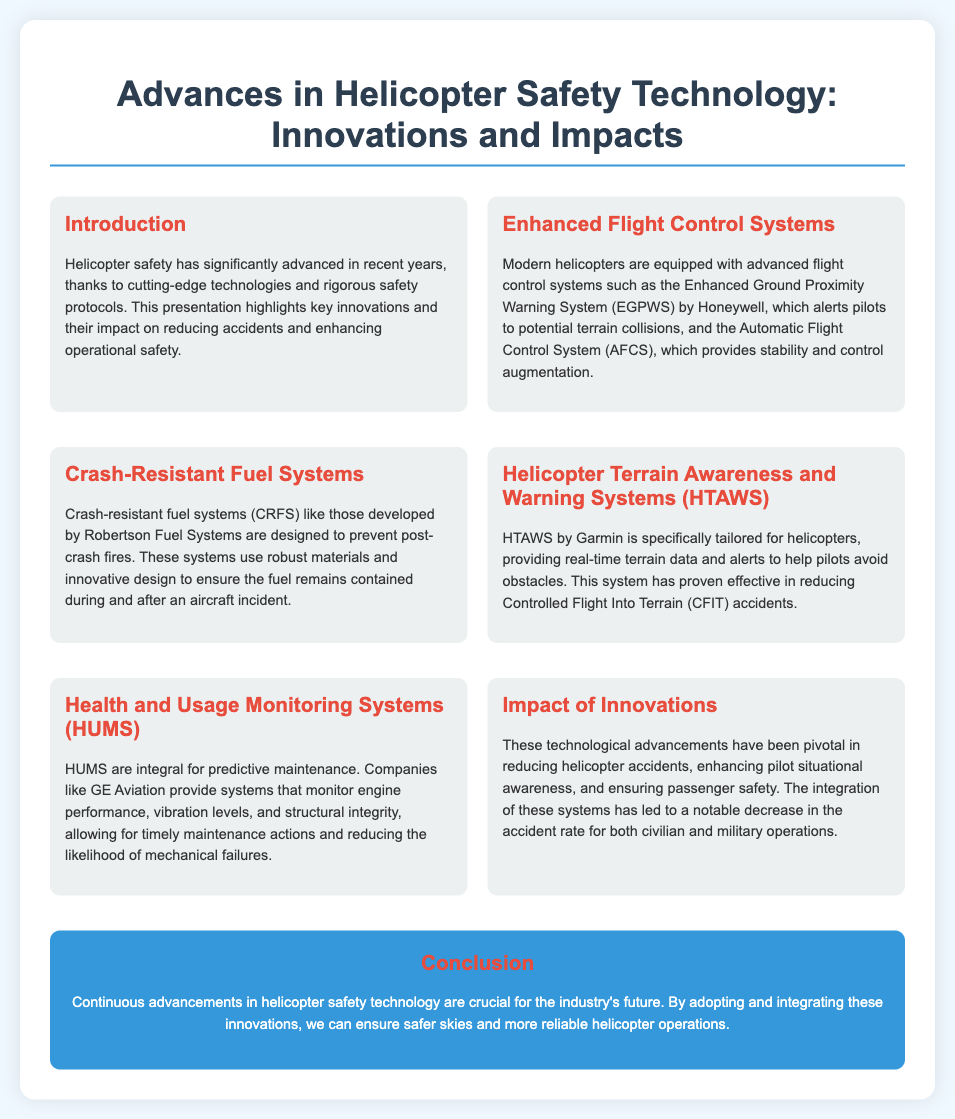What is the title of the presentation? The title is presented at the top of the slide and outlines the main topic being discussed.
Answer: Advances in Helicopter Safety Technology: Innovations and Impacts Who developed the Enhanced Ground Proximity Warning System? The document specifies the company responsible for the Enhanced Ground Proximity Warning System, which is mentioned in the section on Enhanced Flight Control Systems.
Answer: Honeywell What type of fuel systems prevent post-crash fires? The specific type of fuel system designed to avoid fires is directly mentioned in the section on Crash-Resistant Fuel Systems.
Answer: Crash-resistant fuel systems What system helps pilots avoid terrain collisions? This system is explicitly described under the Helicopter Terrain Awareness and Warning Systems section in the document.
Answer: HTAWS What does HUMS stand for? The acronym for the monitoring system mentioned in the Health and Usage Monitoring Systems section is defined in that section.
Answer: Health and Usage Monitoring Systems How have technological advancements affected helicopter accidents? The document summarizes the overall impact of these technologies on accident rates, drawing from multiple sections.
Answer: Decrease What is a key benefit of the Automatic Flight Control System (AFCS)? This benefit is outlined in the section discussing Enhanced Flight Control Systems and speaks to pilot control improvements.
Answer: Stability and control augmentation What color is used for the conclusion section? The document describes the color of the conclusion section, which is highlighted in the visual representation of the slide.
Answer: Blue What are the primary issues that these innovations address? The document hints at what problems are being mitigated through the advancements discussed throughout the presentation.
Answer: Safety and accident reduction 